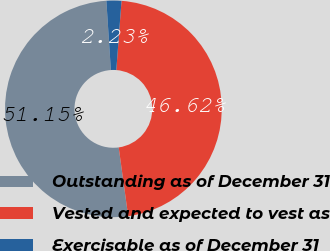Convert chart. <chart><loc_0><loc_0><loc_500><loc_500><pie_chart><fcel>Outstanding as of December 31<fcel>Vested and expected to vest as<fcel>Exercisable as of December 31<nl><fcel>51.15%<fcel>46.62%<fcel>2.23%<nl></chart> 